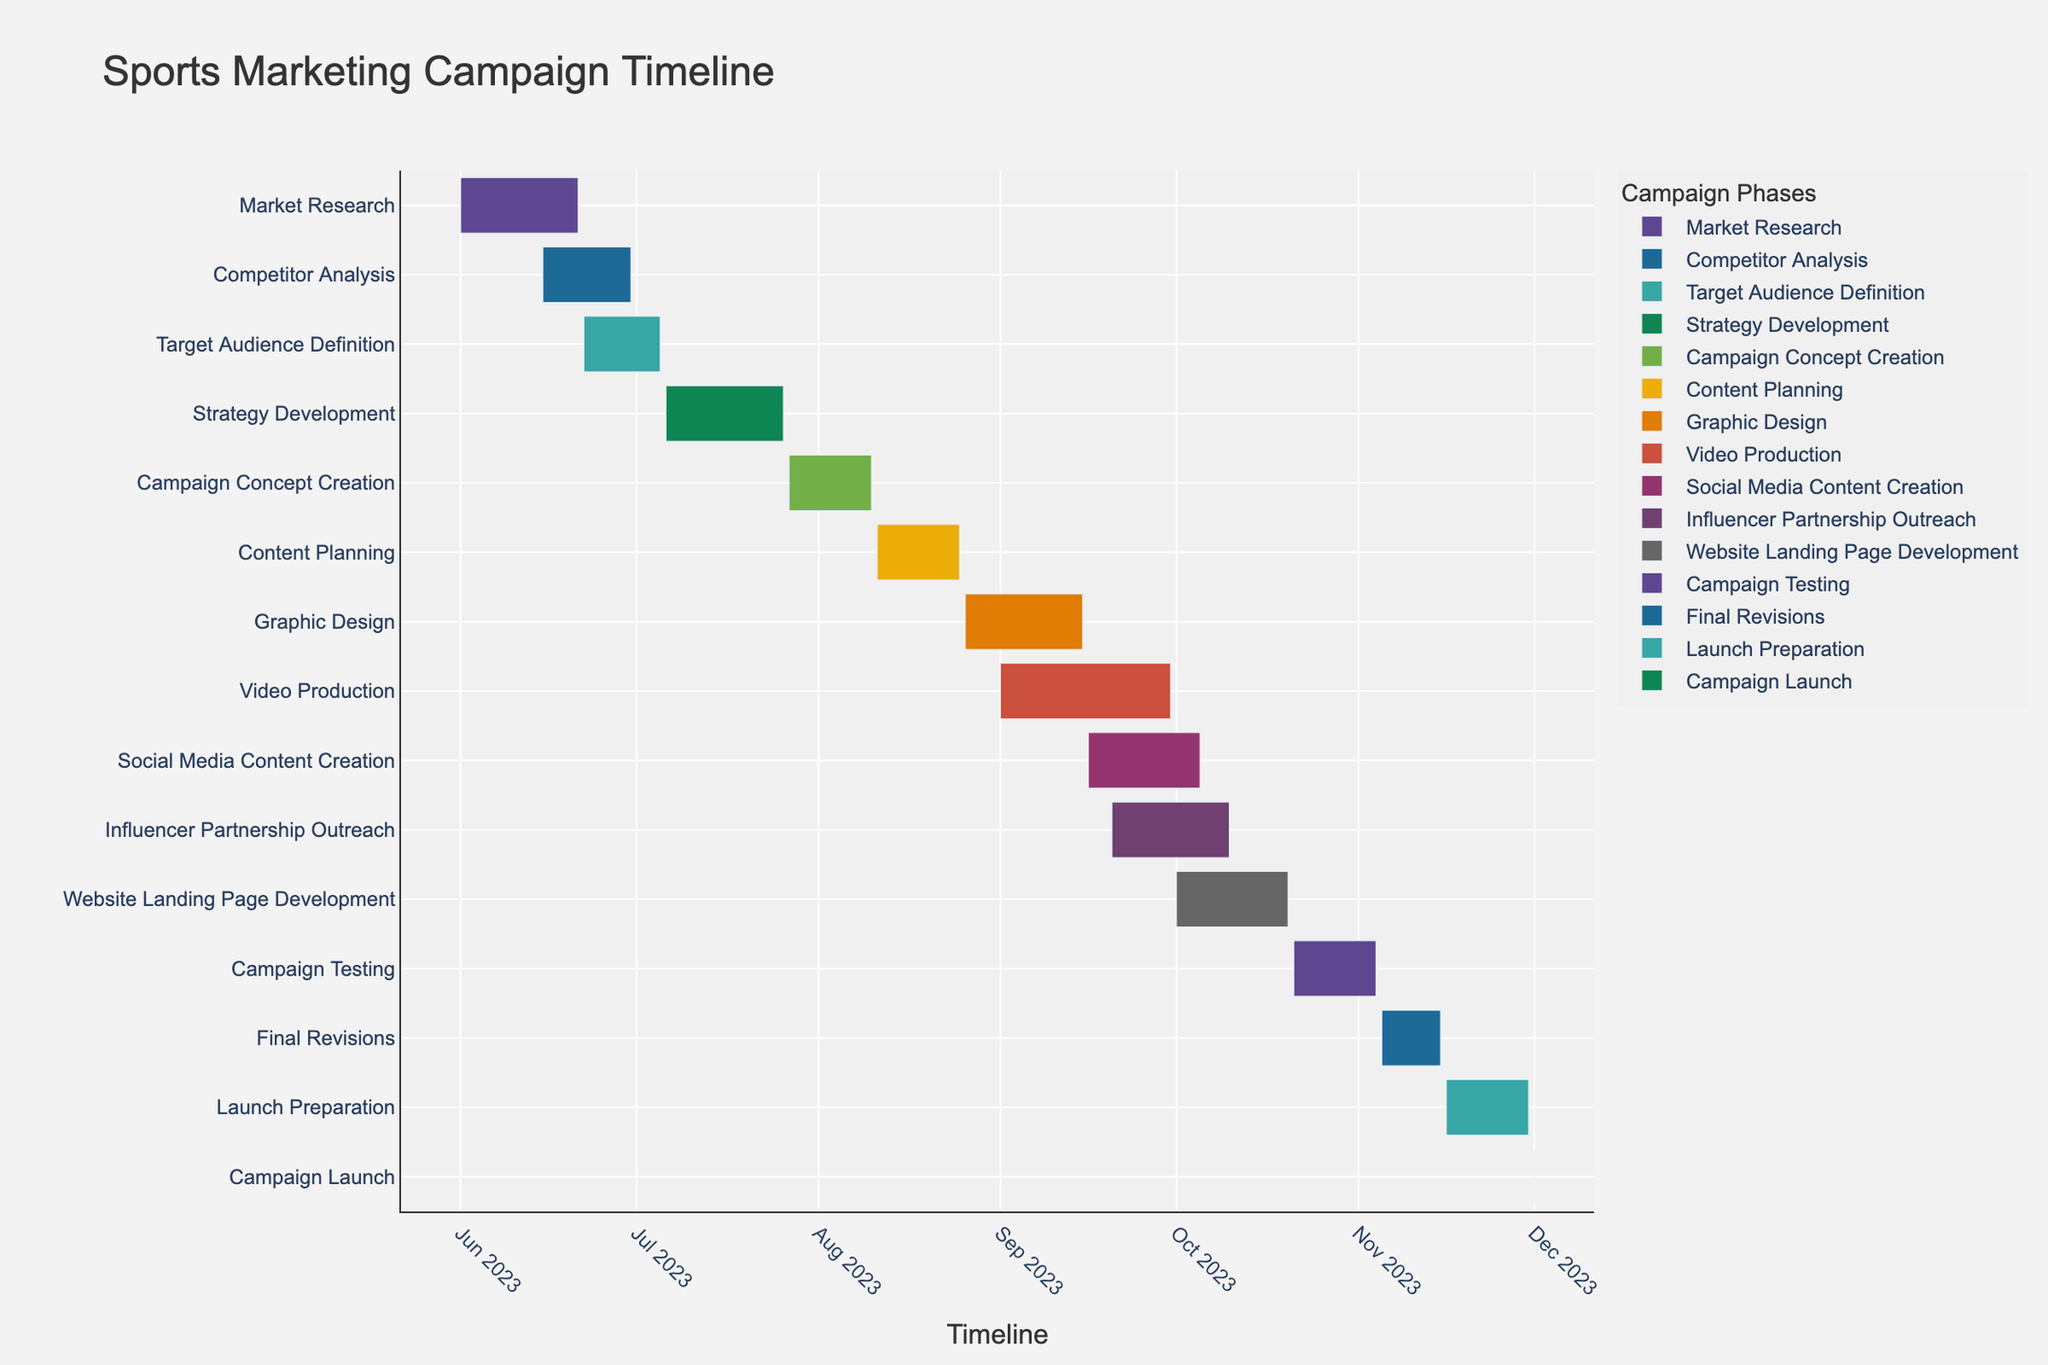What is the total duration of the "Market Research" phase? To find the total duration of the "Market Research" phase, look at the start and end dates. The "Market Research" phase starts on June 1, 2023, and ends on June 21, 2023. Count the number of days between these dates.
Answer: 21 days Which task has the shortest duration? Check each task's duration by subtracting the start date from the end date. The task that lasts for the least number of days is the shortest duration. The "Campaign Launch" task runs only for 1 day.
Answer: Campaign Launch What is the combined duration of "Video Production" and "Social Media Content Creation"? First, find the duration of each task separately. "Video Production" runs from September 1, 2023, to September 30, 2023, which is 30 days. "Social Media Content Creation" runs from September 16, 2023, to October 5, 2023, which is 20 days. Then, add these durations together: 30 + 20.
Answer: 50 days Which phase starts first, "Competitor Analysis" or "Target Audience Definition"? Compare the start dates of "Competitor Analysis" and "Target Audience Definition". "Competitor Analysis" starts on June 15, 2023, and "Target Audience Definition" starts on June 22, 2023. Since June 15 is earlier than June 22, "Competitor Analysis" starts first.
Answer: Competitor Analysis How many tasks overlap with the "Strategy Development" phase? The "Strategy Development" phase runs from July 6, 2023, to July 26, 2023. Check which tasks have start and end dates that fall within this range. "Target Audience Definition" overlaps from July 6 to July 5, "Campaign Concept Creation" overlaps from July 27 to July 26. Therefore, there is an overlap with both tasks.
Answer: 2 tasks What is the duration of the entire project from start to launch? Identify the start date of the first task and the end date of the last task. "Market Research" starts on June 1, 2023, and "Campaign Launch" ends on December 1, 2023. Calculate the number of days between these two dates.
Answer: 184 days During which month does "Graphic Design" start? Look at the start date of "Graphic Design". It starts on August 26, 2023.
Answer: August Which tasks are ongoing during September 2023? Find tasks whose start and end dates fall within or overlap with September 2023. These tasks are "Graphic Design" (August 26 to September 15), "Video Production" (September 1 to September 30), "Social Media Content Creation" (September 16 to October 5), and "Influencer Partnership Outreach" (September 20 to October 10).
Answer: 4 tasks Which task has the longest duration? Check each task's duration by subtracting the start date from the end date. The task with the longest duration is "Video Production", which lasts 30 days.
Answer: Video Production 